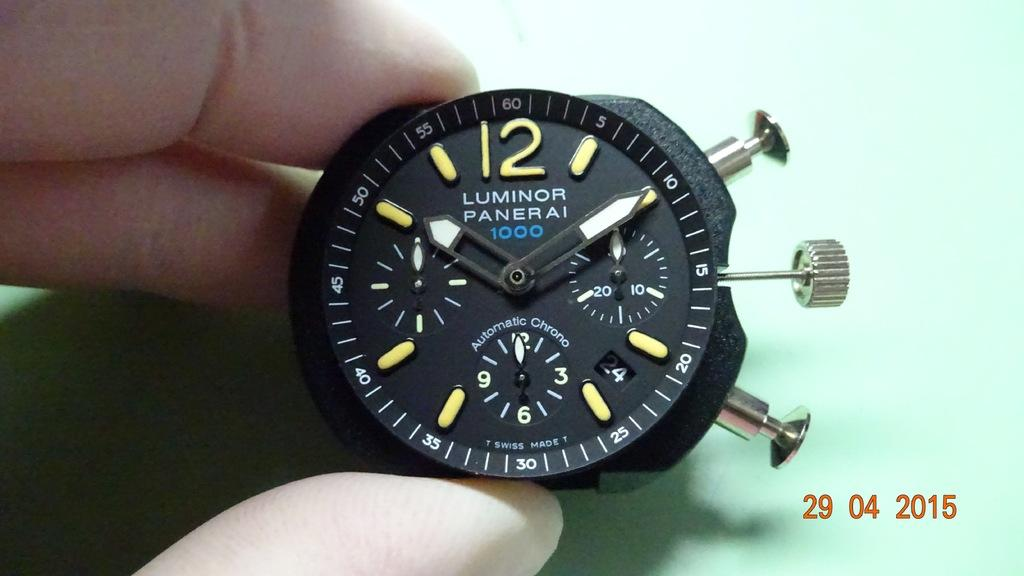<image>
Render a clear and concise summary of the photo. On April 29th, 2015 someone holds this Luminor Panerai 1000 wristwatch showing the time of 10:10. 